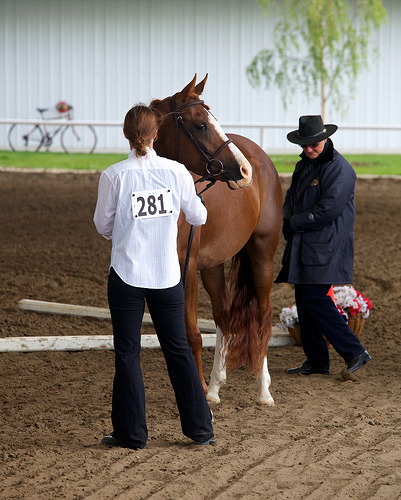<image>
Can you confirm if the man is on the horse? No. The man is not positioned on the horse. They may be near each other, but the man is not supported by or resting on top of the horse. Where is the women in relation to the horse? Is it on the horse? No. The women is not positioned on the horse. They may be near each other, but the women is not supported by or resting on top of the horse. Where is the horse in relation to the woman? Is it behind the woman? Yes. From this viewpoint, the horse is positioned behind the woman, with the woman partially or fully occluding the horse. Where is the man in relation to the flowers? Is it behind the flowers? No. The man is not behind the flowers. From this viewpoint, the man appears to be positioned elsewhere in the scene. 